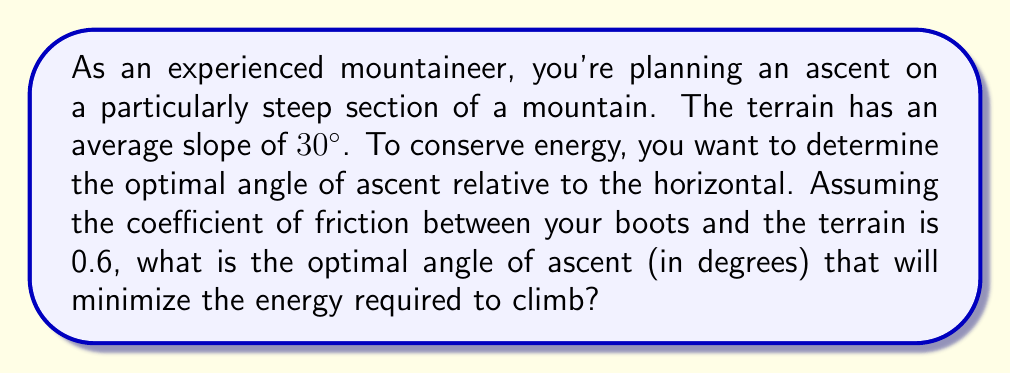Provide a solution to this math problem. To solve this problem, we need to consider the forces acting on the climber and use principles of physics and optimization. Let's break it down step-by-step:

1) First, we need to understand the forces involved:
   - Gravity (always vertical)
   - Normal force (perpendicular to the slope)
   - Friction force (parallel to the slope, opposing motion)
   - Applied force (the climber's effort)

2) Let $\theta$ be the angle of the slope (30°), and $\phi$ be the angle of ascent relative to the horizontal that we're trying to optimize.

3) The work done against gravity is constant regardless of the path taken, so we focus on minimizing the work done against friction.

4) The normal force is given by:
   $$F_N = mg \cos(\phi - \theta)$$
   where $m$ is the climber's mass and $g$ is the acceleration due to gravity.

5) The friction force is:
   $$F_f = \mu F_N = \mu mg \cos(\phi - \theta)$$
   where $\mu$ is the coefficient of friction (0.6 in this case).

6) The distance traveled along the slope to gain a vertical height $h$ is:
   $$d = \frac{h}{\sin \phi}$$

7) The work done against friction is:
   $$W = F_f d = \mu mg \cos(\phi - \theta) \frac{h}{\sin \phi}$$

8) To minimize this, we differentiate with respect to $\phi$ and set it to zero:
   $$\frac{d}{d\phi}(\mu mg h \cot \phi \cos(\phi - \theta)) = 0$$

9) Solving this equation leads to the optimal angle condition:
   $$\tan \phi = \sqrt{1 + \mu \tan \theta}$$

10) Substituting our known values:
    $$\tan \phi = \sqrt{1 + 0.6 \tan 30°} \approx 1.2808$$

11) Taking the inverse tangent:
    $$\phi = \tan^{-1}(1.2808) \approx 52.0°$$

Therefore, the optimal angle of ascent is approximately 52.0° relative to the horizontal.
Answer: The optimal angle of ascent is approximately 52.0°. 